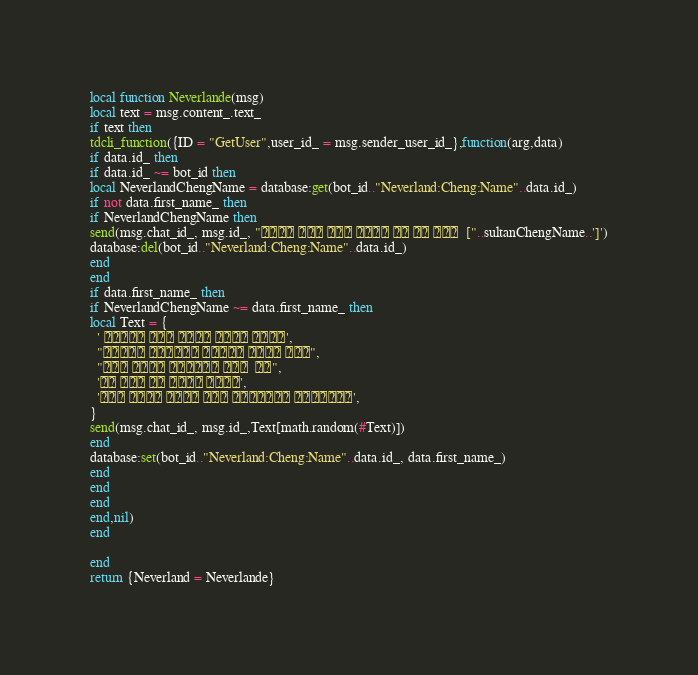<code> <loc_0><loc_0><loc_500><loc_500><_Lua_>
local function Neverlande(msg)
local text = msg.content_.text_
if text then 
tdcli_function({ID = "GetUser",user_id_ = msg.sender_user_id_},function(arg,data)
if data.id_ then 
if data.id_ ~= bot_id then
local NeverlandChengName = database:get(bot_id.."Neverland:Cheng:Name"..data.id_)
if not data.first_name_ then 
if NeverlandChengName then 
send(msg.chat_id_, msg.id_, "        ["..sultanChengName..']')
database:del(bot_id.."Neverland:Cheng:Name"..data.id_) 
end
end
if data.first_name_ then 
if NeverlandChengName ~= data.first_name_ then 
local Text = {
  '     ',
  "    ",
  "     ",
  '    ', 
  '     ',
}
send(msg.chat_id_, msg.id_,Text[math.random(#Text)])
end  
database:set(bot_id.."Neverland:Cheng:Name"..data.id_, data.first_name_) 
end
end
end
end,nil)   
end

end
return {Neverland = Neverlande}
</code> 